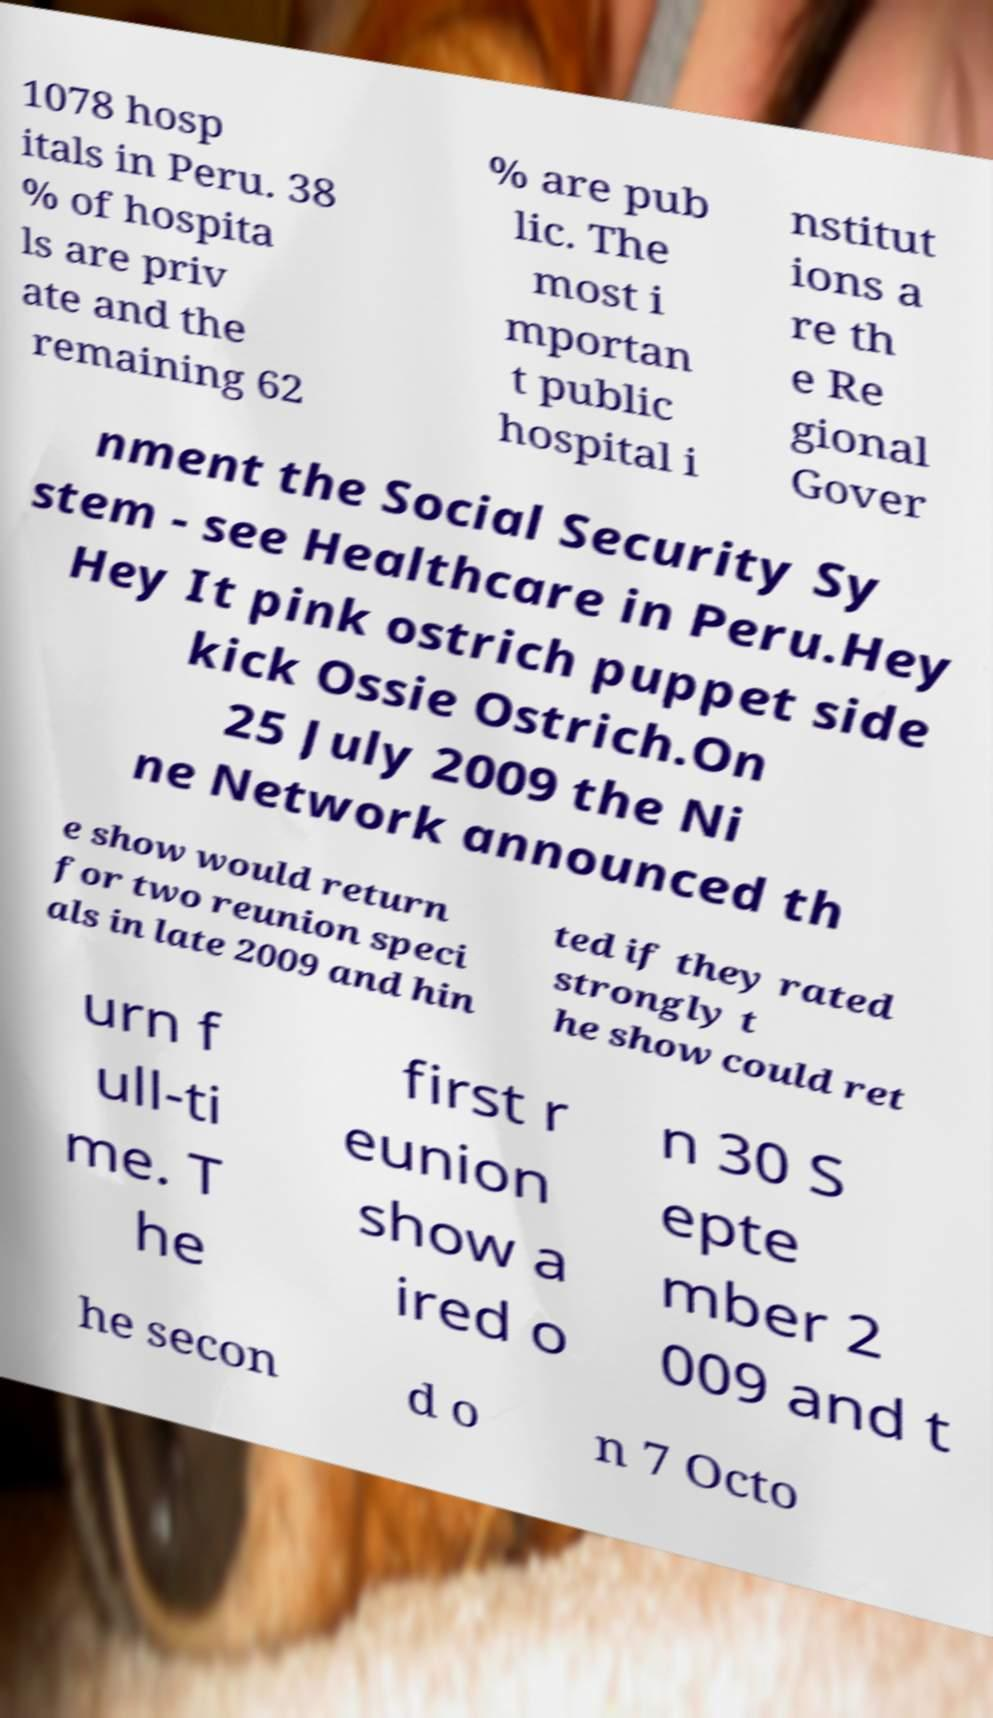Please identify and transcribe the text found in this image. 1078 hosp itals in Peru. 38 % of hospita ls are priv ate and the remaining 62 % are pub lic. The most i mportan t public hospital i nstitut ions a re th e Re gional Gover nment the Social Security Sy stem - see Healthcare in Peru.Hey Hey It pink ostrich puppet side kick Ossie Ostrich.On 25 July 2009 the Ni ne Network announced th e show would return for two reunion speci als in late 2009 and hin ted if they rated strongly t he show could ret urn f ull-ti me. T he first r eunion show a ired o n 30 S epte mber 2 009 and t he secon d o n 7 Octo 